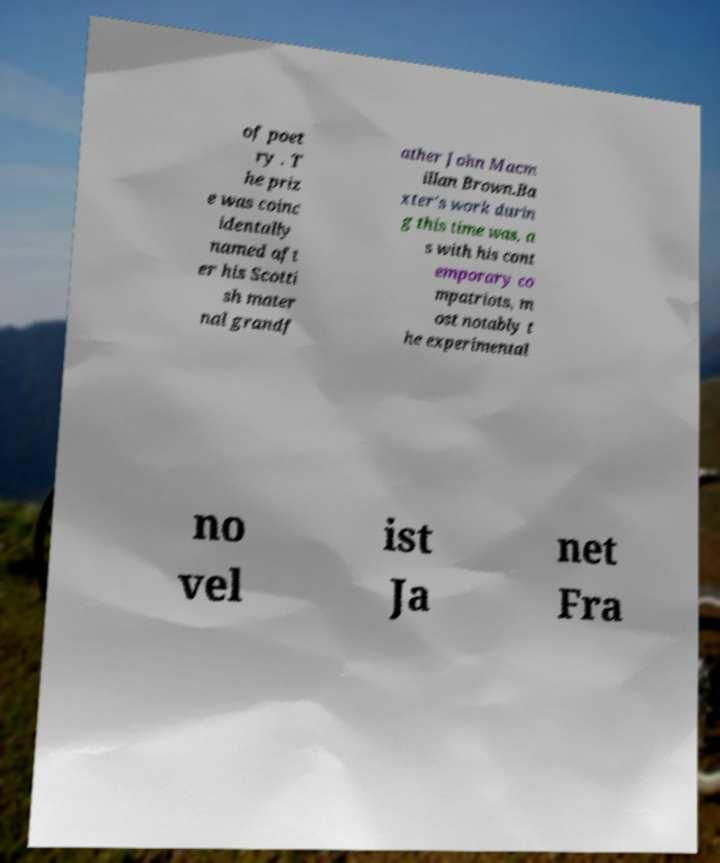There's text embedded in this image that I need extracted. Can you transcribe it verbatim? of poet ry . T he priz e was coinc identally named aft er his Scotti sh mater nal grandf ather John Macm illan Brown.Ba xter's work durin g this time was, a s with his cont emporary co mpatriots, m ost notably t he experimental no vel ist Ja net Fra 